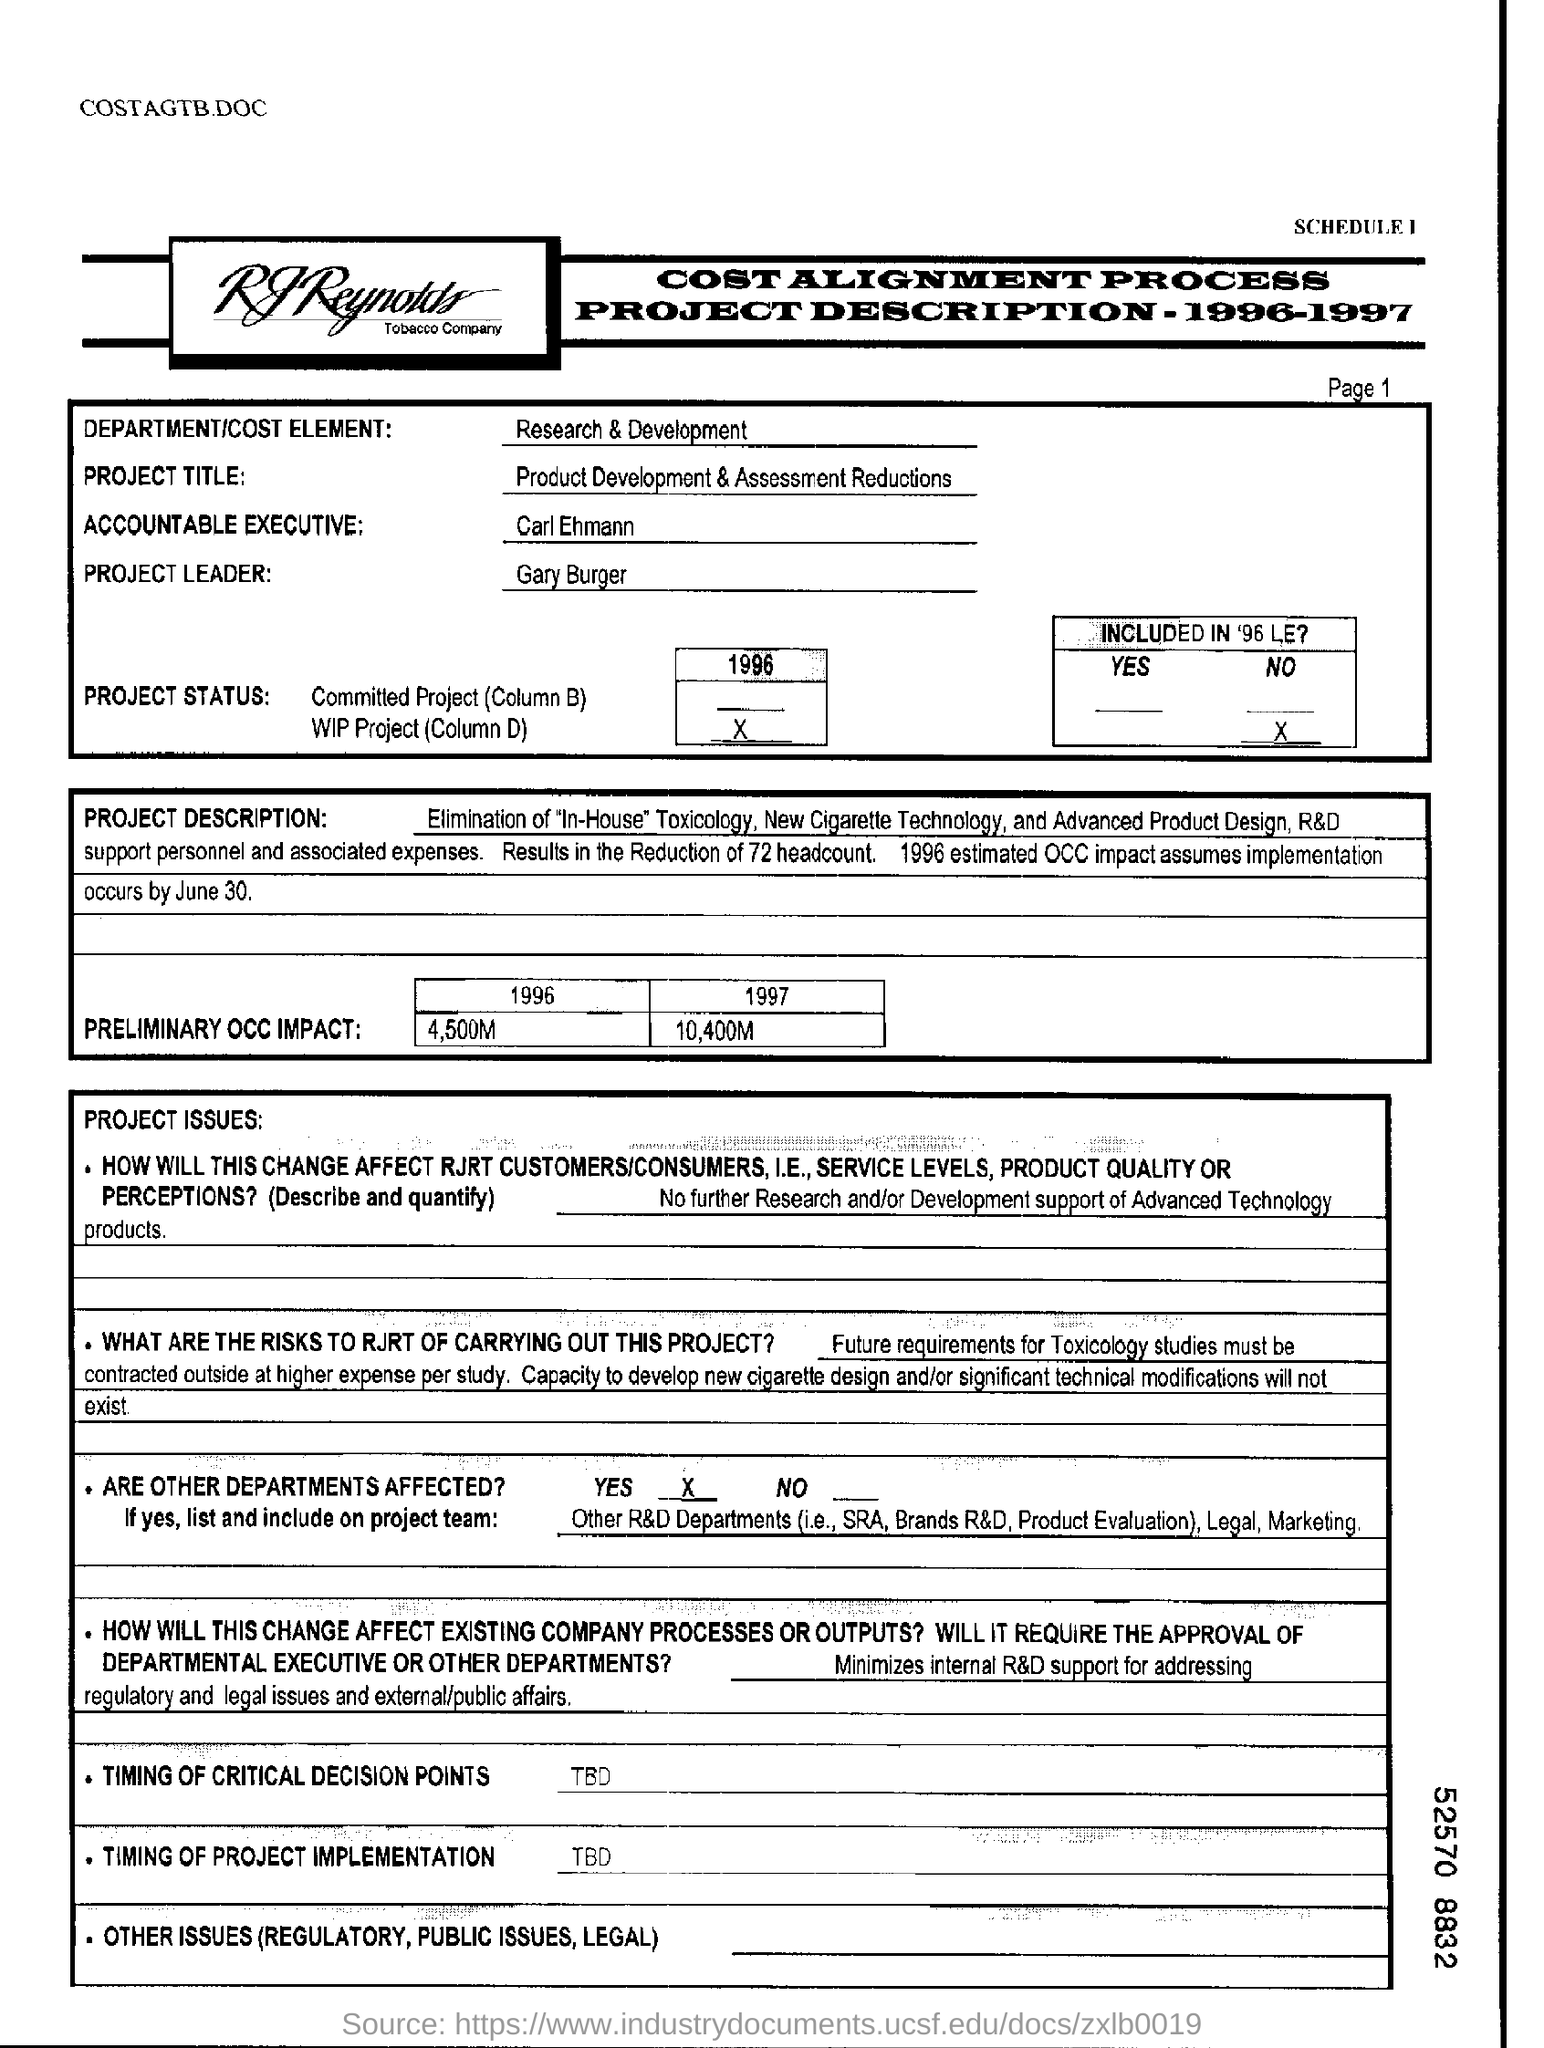Indicate a few pertinent items in this graphic. The research and development department is involved. In the year 1997, the preliminary OCC impact was estimated to be approximately 10,400 million. The individual named Gary Burger is the project leader. 